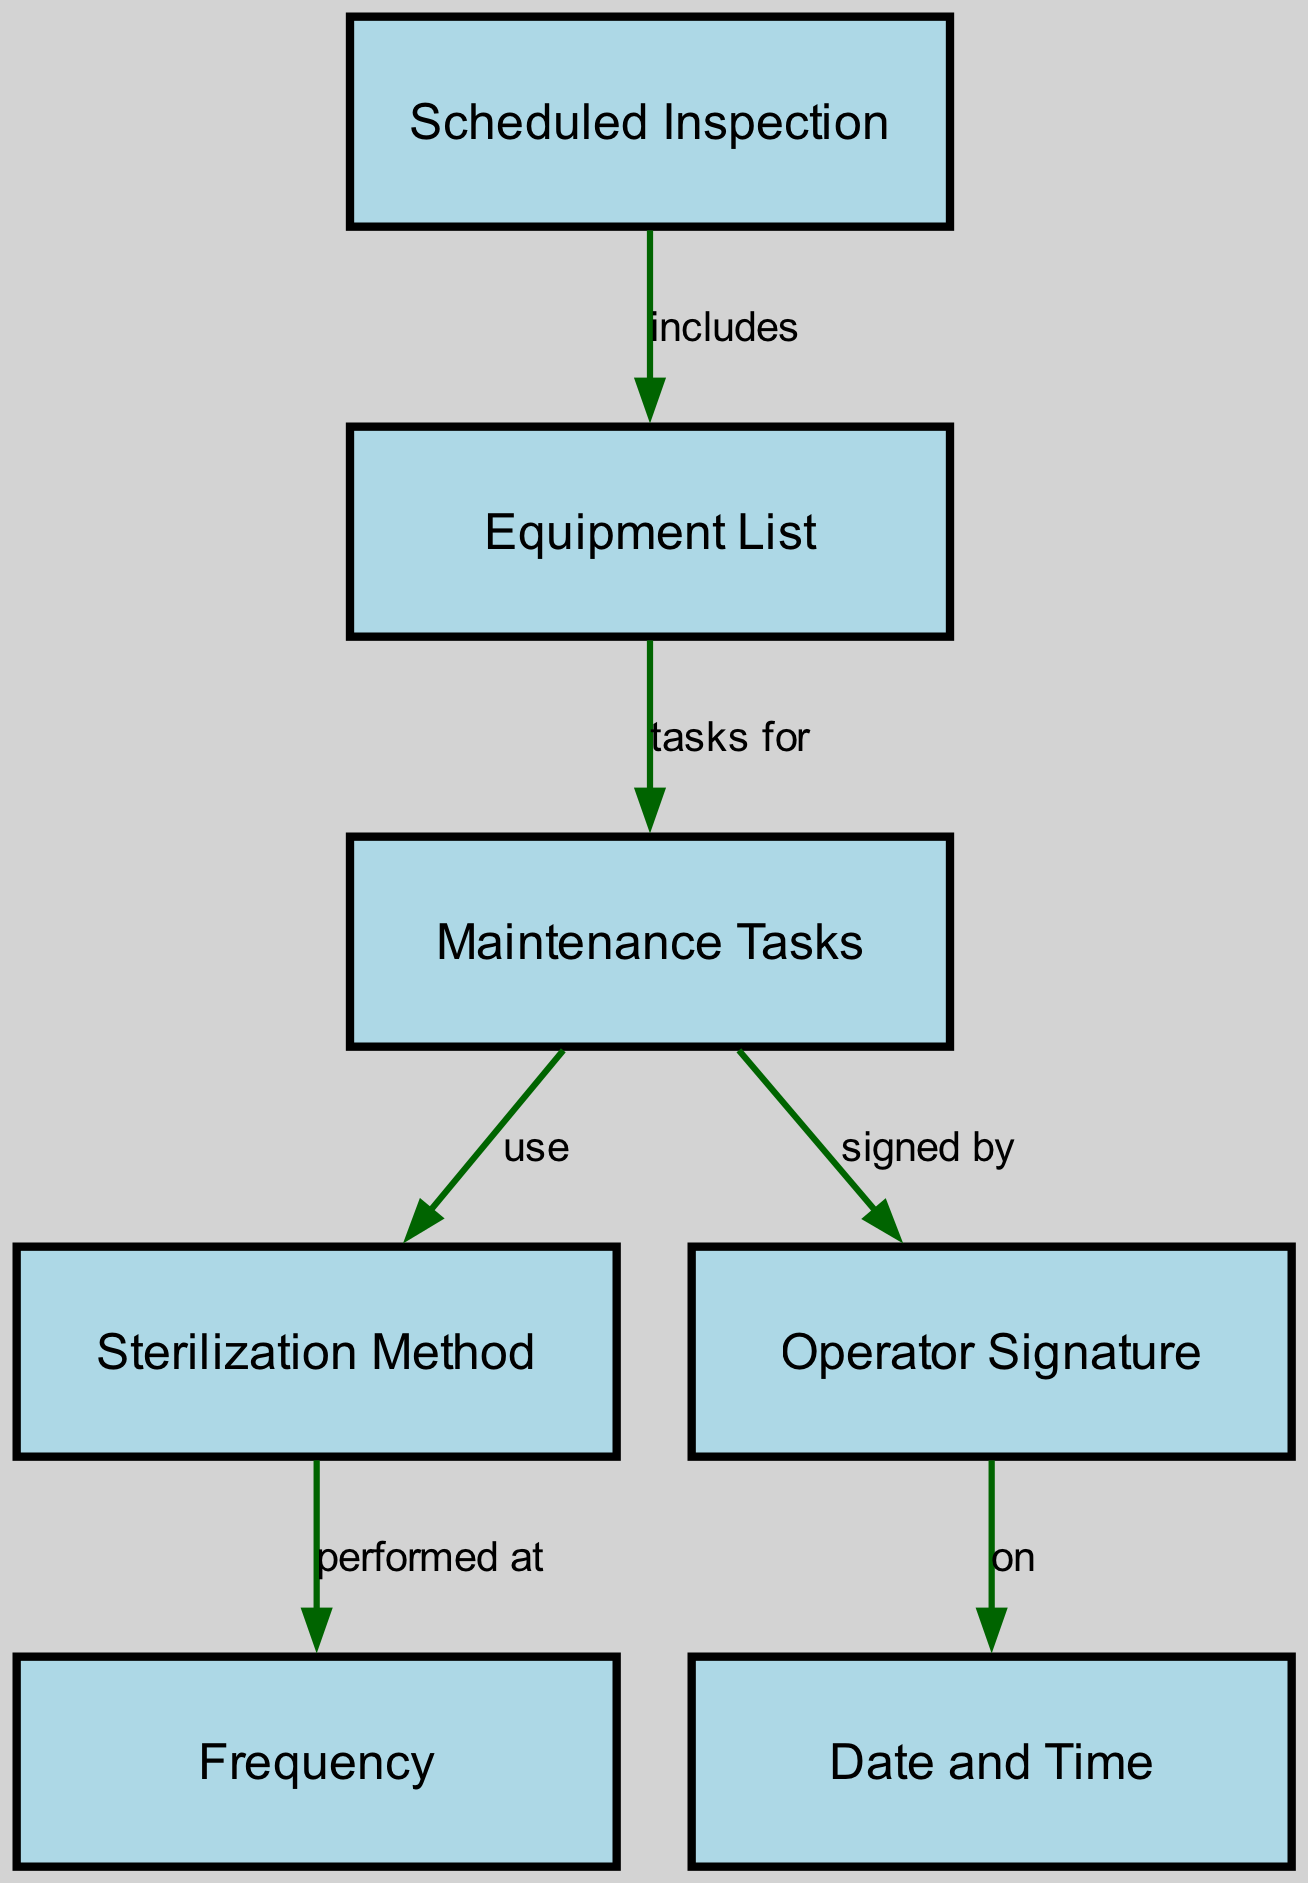What is the first step in the sterilization maintenance process? The first step in the sterilization maintenance process shown in the diagram is "Scheduled Inspection," which is indicated as the starting node.
Answer: Scheduled Inspection How many nodes are present in the diagram? Counting all the nodes in the diagram reveals there are six distinct nodes, each representing a different aspect of the maintenance schedule.
Answer: 6 What relationship exists between "Equipment List" and "Maintenance Tasks"? The diagram indicates a direct relationship where "Equipment List" includes "Maintenance Tasks," showing that the tasks pertain to the equipment listed.
Answer: includes Which task is performed at a specific frequency? The task related to "Sterilization Method" is noted to be "performed at" a specific "Frequency" in the maintenance process, connecting sterilization to its timing.
Answer: performed at What document needs to be signed by the operator? The "Operator Signature" is required to validate the completion of "Maintenance Tasks," ensuring that the operator has acknowledged the task.
Answer: Maintenance Tasks Which node is connected to "Operator Signature"? The "Operator Signature" node is connected to the "Date and Time" node, indicating that an operator's signature is recorded on a specific date and time.
Answer: Date and Time If sterilization methods are employed, what must be done with the maintenance tasks? The relationship suggests that "Maintenance Tasks" must use a corresponding "Sterilization Method," indicating that tasks must follow a particular sterilization procedure.
Answer: use At what point in the diagram does the frequency appear? The "Frequency" node appears as a result of the "Sterilization Method," indicating that the method dictates how often the tasks should occur in the maintenance schedule.
Answer: Sterilization Method What is required at the end of the maintenance documentation process? The last step shown in the diagram indicates that the "Date and Time" must be documented, which signifies the completion of the maintenance log.
Answer: Date and Time 